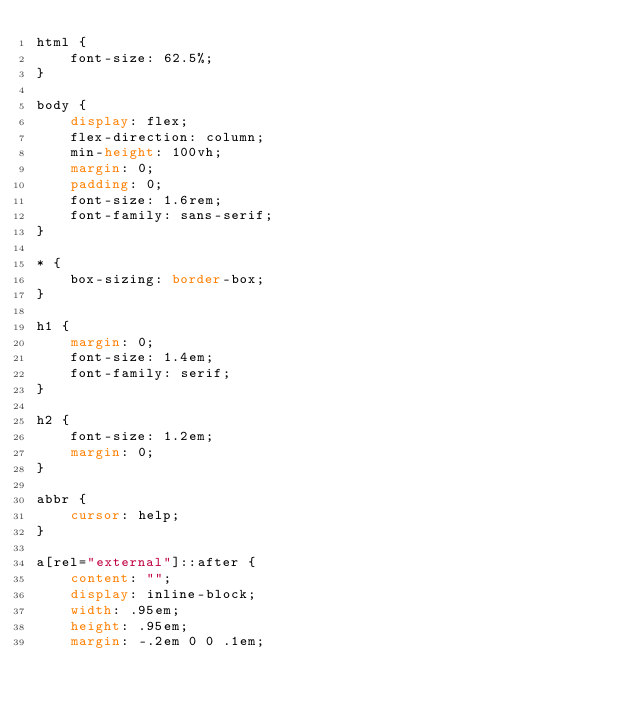Convert code to text. <code><loc_0><loc_0><loc_500><loc_500><_CSS_>html {
    font-size: 62.5%;
}

body {
    display: flex;
    flex-direction: column;
    min-height: 100vh;
    margin: 0;
    padding: 0;
    font-size: 1.6rem;
    font-family: sans-serif;
}

* {
    box-sizing: border-box;
}

h1 {
    margin: 0;
    font-size: 1.4em;
    font-family: serif;
}

h2 {
    font-size: 1.2em;
    margin: 0;
}

abbr {
    cursor: help;
}

a[rel="external"]::after {
    content: "";
    display: inline-block;
    width: .95em;
    height: .95em;
    margin: -.2em 0 0 .1em;</code> 